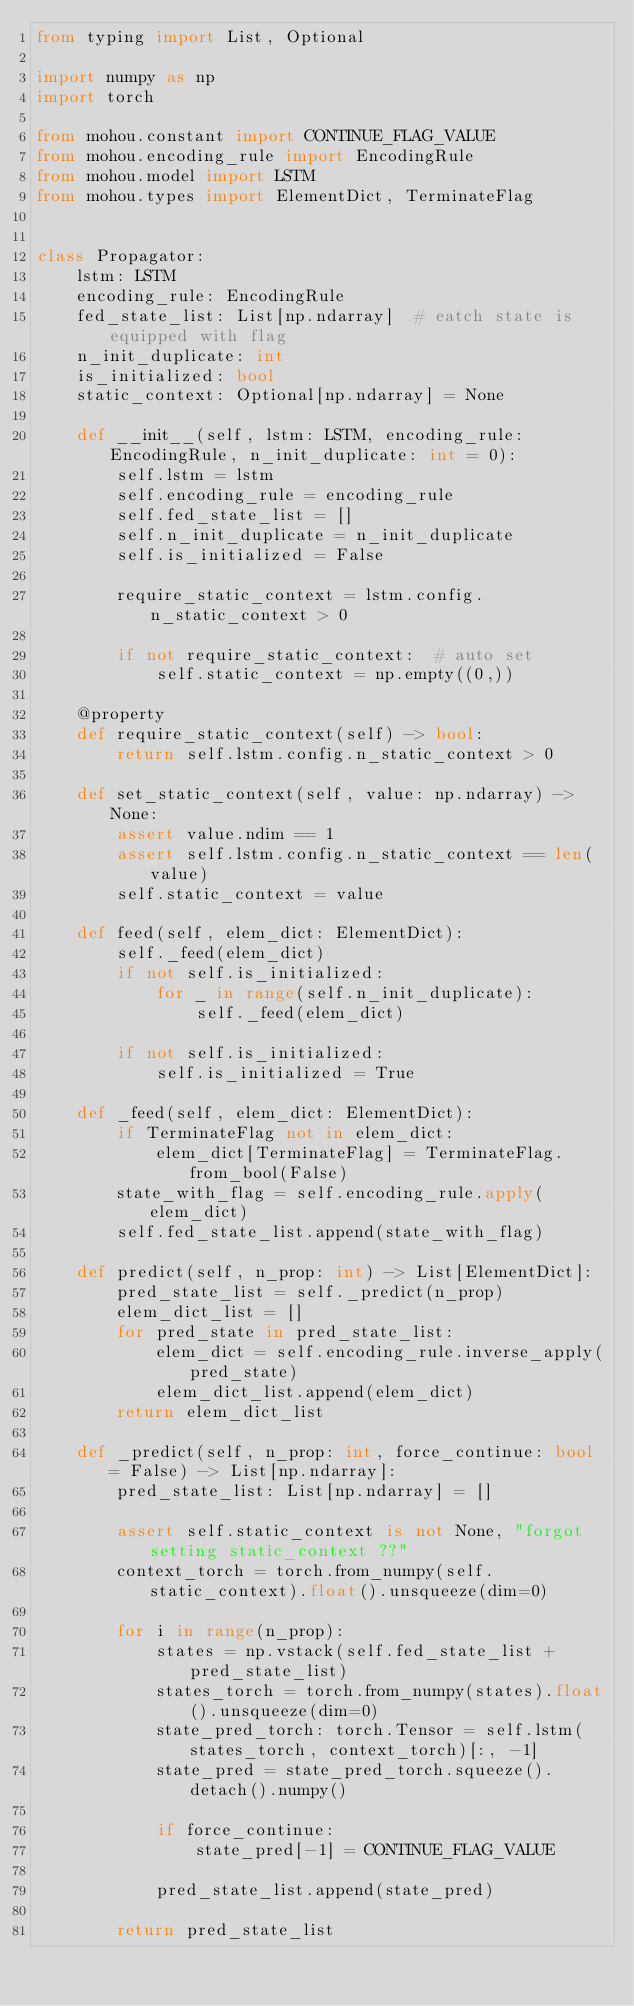<code> <loc_0><loc_0><loc_500><loc_500><_Python_>from typing import List, Optional

import numpy as np
import torch

from mohou.constant import CONTINUE_FLAG_VALUE
from mohou.encoding_rule import EncodingRule
from mohou.model import LSTM
from mohou.types import ElementDict, TerminateFlag


class Propagator:
    lstm: LSTM
    encoding_rule: EncodingRule
    fed_state_list: List[np.ndarray]  # eatch state is equipped with flag
    n_init_duplicate: int
    is_initialized: bool
    static_context: Optional[np.ndarray] = None

    def __init__(self, lstm: LSTM, encoding_rule: EncodingRule, n_init_duplicate: int = 0):
        self.lstm = lstm
        self.encoding_rule = encoding_rule
        self.fed_state_list = []
        self.n_init_duplicate = n_init_duplicate
        self.is_initialized = False

        require_static_context = lstm.config.n_static_context > 0

        if not require_static_context:  # auto set
            self.static_context = np.empty((0,))

    @property
    def require_static_context(self) -> bool:
        return self.lstm.config.n_static_context > 0

    def set_static_context(self, value: np.ndarray) -> None:
        assert value.ndim == 1
        assert self.lstm.config.n_static_context == len(value)
        self.static_context = value

    def feed(self, elem_dict: ElementDict):
        self._feed(elem_dict)
        if not self.is_initialized:
            for _ in range(self.n_init_duplicate):
                self._feed(elem_dict)

        if not self.is_initialized:
            self.is_initialized = True

    def _feed(self, elem_dict: ElementDict):
        if TerminateFlag not in elem_dict:
            elem_dict[TerminateFlag] = TerminateFlag.from_bool(False)
        state_with_flag = self.encoding_rule.apply(elem_dict)
        self.fed_state_list.append(state_with_flag)

    def predict(self, n_prop: int) -> List[ElementDict]:
        pred_state_list = self._predict(n_prop)
        elem_dict_list = []
        for pred_state in pred_state_list:
            elem_dict = self.encoding_rule.inverse_apply(pred_state)
            elem_dict_list.append(elem_dict)
        return elem_dict_list

    def _predict(self, n_prop: int, force_continue: bool = False) -> List[np.ndarray]:
        pred_state_list: List[np.ndarray] = []

        assert self.static_context is not None, "forgot setting static_context ??"
        context_torch = torch.from_numpy(self.static_context).float().unsqueeze(dim=0)

        for i in range(n_prop):
            states = np.vstack(self.fed_state_list + pred_state_list)
            states_torch = torch.from_numpy(states).float().unsqueeze(dim=0)
            state_pred_torch: torch.Tensor = self.lstm(states_torch, context_torch)[:, -1]
            state_pred = state_pred_torch.squeeze().detach().numpy()

            if force_continue:
                state_pred[-1] = CONTINUE_FLAG_VALUE

            pred_state_list.append(state_pred)

        return pred_state_list
</code> 